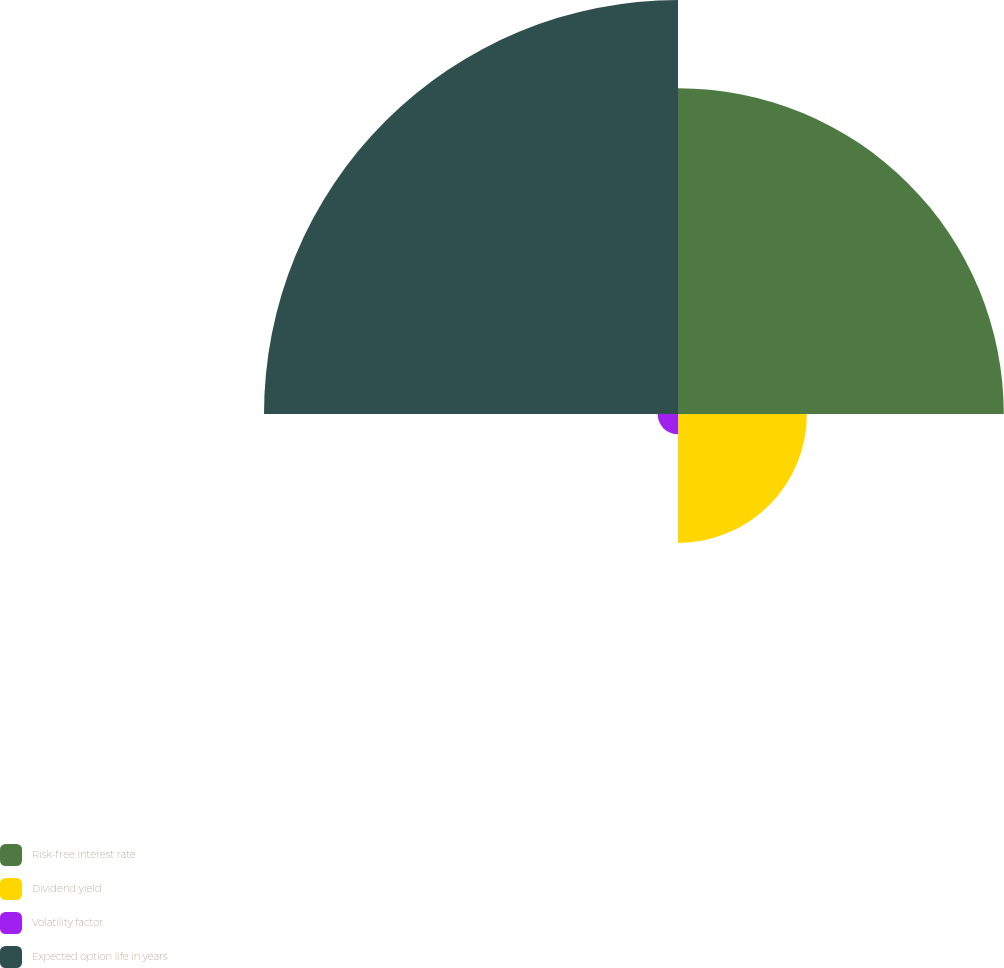Convert chart. <chart><loc_0><loc_0><loc_500><loc_500><pie_chart><fcel>Risk-free interest rate<fcel>Dividend yield<fcel>Volatility factor<fcel>Expected option life in years<nl><fcel>36.64%<fcel>14.5%<fcel>2.29%<fcel>46.56%<nl></chart> 